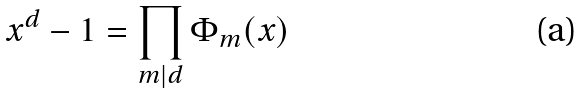Convert formula to latex. <formula><loc_0><loc_0><loc_500><loc_500>x ^ { d } - 1 = \prod _ { m | d } \Phi _ { m } ( x )</formula> 